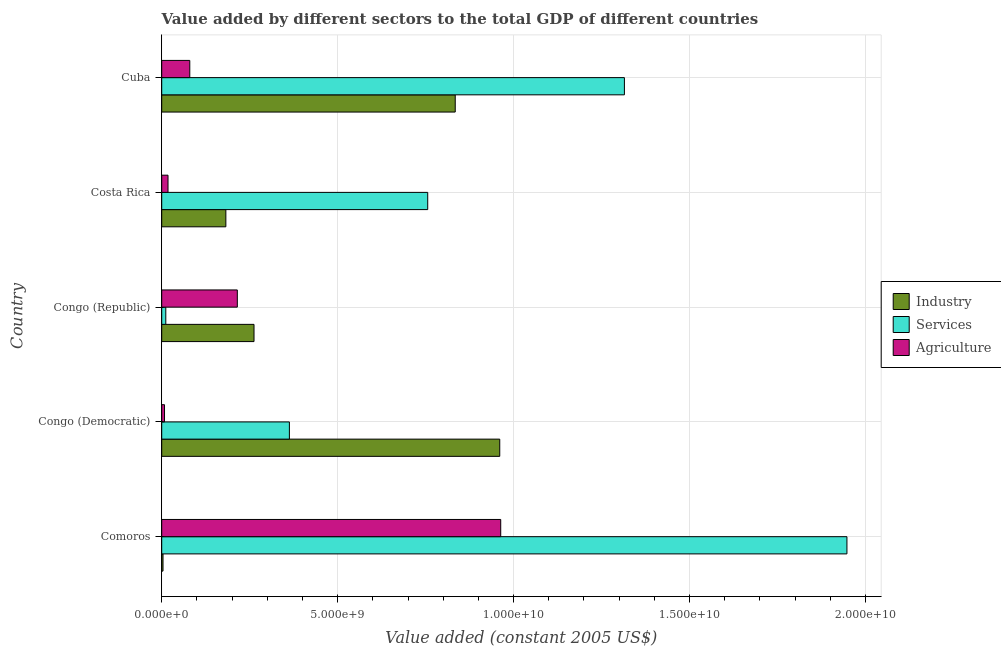How many different coloured bars are there?
Offer a terse response. 3. How many groups of bars are there?
Your answer should be very brief. 5. How many bars are there on the 5th tick from the bottom?
Provide a succinct answer. 3. What is the label of the 3rd group of bars from the top?
Ensure brevity in your answer.  Congo (Republic). In how many cases, is the number of bars for a given country not equal to the number of legend labels?
Offer a very short reply. 0. What is the value added by services in Cuba?
Offer a very short reply. 1.32e+1. Across all countries, what is the maximum value added by agricultural sector?
Provide a short and direct response. 9.64e+09. Across all countries, what is the minimum value added by industrial sector?
Offer a very short reply. 3.69e+07. In which country was the value added by services maximum?
Your response must be concise. Comoros. In which country was the value added by services minimum?
Your response must be concise. Congo (Republic). What is the total value added by agricultural sector in the graph?
Keep it short and to the point. 1.28e+1. What is the difference between the value added by industrial sector in Comoros and that in Costa Rica?
Ensure brevity in your answer.  -1.79e+09. What is the difference between the value added by agricultural sector in Congo (Democratic) and the value added by industrial sector in Comoros?
Keep it short and to the point. 4.30e+07. What is the average value added by agricultural sector per country?
Your answer should be compact. 2.57e+09. What is the difference between the value added by agricultural sector and value added by industrial sector in Costa Rica?
Ensure brevity in your answer.  -1.64e+09. What is the ratio of the value added by services in Costa Rica to that in Cuba?
Make the answer very short. 0.57. Is the value added by industrial sector in Congo (Republic) less than that in Costa Rica?
Your answer should be very brief. No. Is the difference between the value added by agricultural sector in Comoros and Costa Rica greater than the difference between the value added by industrial sector in Comoros and Costa Rica?
Provide a succinct answer. Yes. What is the difference between the highest and the second highest value added by services?
Make the answer very short. 6.32e+09. What is the difference between the highest and the lowest value added by services?
Make the answer very short. 1.94e+1. In how many countries, is the value added by industrial sector greater than the average value added by industrial sector taken over all countries?
Offer a very short reply. 2. Is the sum of the value added by industrial sector in Congo (Democratic) and Congo (Republic) greater than the maximum value added by services across all countries?
Give a very brief answer. No. What does the 2nd bar from the top in Congo (Democratic) represents?
Provide a succinct answer. Services. What does the 3rd bar from the bottom in Costa Rica represents?
Your response must be concise. Agriculture. Is it the case that in every country, the sum of the value added by industrial sector and value added by services is greater than the value added by agricultural sector?
Make the answer very short. Yes. Are all the bars in the graph horizontal?
Provide a succinct answer. Yes. How many countries are there in the graph?
Your answer should be compact. 5. What is the difference between two consecutive major ticks on the X-axis?
Your answer should be compact. 5.00e+09. Does the graph contain any zero values?
Provide a short and direct response. No. How many legend labels are there?
Provide a succinct answer. 3. How are the legend labels stacked?
Your answer should be compact. Vertical. What is the title of the graph?
Offer a terse response. Value added by different sectors to the total GDP of different countries. What is the label or title of the X-axis?
Keep it short and to the point. Value added (constant 2005 US$). What is the Value added (constant 2005 US$) in Industry in Comoros?
Ensure brevity in your answer.  3.69e+07. What is the Value added (constant 2005 US$) in Services in Comoros?
Ensure brevity in your answer.  1.95e+1. What is the Value added (constant 2005 US$) of Agriculture in Comoros?
Ensure brevity in your answer.  9.64e+09. What is the Value added (constant 2005 US$) in Industry in Congo (Democratic)?
Make the answer very short. 9.61e+09. What is the Value added (constant 2005 US$) of Services in Congo (Democratic)?
Give a very brief answer. 3.63e+09. What is the Value added (constant 2005 US$) of Agriculture in Congo (Democratic)?
Provide a succinct answer. 7.98e+07. What is the Value added (constant 2005 US$) of Industry in Congo (Republic)?
Your response must be concise. 2.62e+09. What is the Value added (constant 2005 US$) of Services in Congo (Republic)?
Your answer should be very brief. 1.16e+08. What is the Value added (constant 2005 US$) in Agriculture in Congo (Republic)?
Offer a terse response. 2.15e+09. What is the Value added (constant 2005 US$) of Industry in Costa Rica?
Your answer should be compact. 1.82e+09. What is the Value added (constant 2005 US$) in Services in Costa Rica?
Make the answer very short. 7.56e+09. What is the Value added (constant 2005 US$) in Agriculture in Costa Rica?
Your answer should be compact. 1.79e+08. What is the Value added (constant 2005 US$) in Industry in Cuba?
Ensure brevity in your answer.  8.34e+09. What is the Value added (constant 2005 US$) in Services in Cuba?
Give a very brief answer. 1.32e+1. What is the Value added (constant 2005 US$) of Agriculture in Cuba?
Your answer should be very brief. 7.98e+08. Across all countries, what is the maximum Value added (constant 2005 US$) in Industry?
Keep it short and to the point. 9.61e+09. Across all countries, what is the maximum Value added (constant 2005 US$) in Services?
Make the answer very short. 1.95e+1. Across all countries, what is the maximum Value added (constant 2005 US$) of Agriculture?
Your answer should be very brief. 9.64e+09. Across all countries, what is the minimum Value added (constant 2005 US$) in Industry?
Keep it short and to the point. 3.69e+07. Across all countries, what is the minimum Value added (constant 2005 US$) in Services?
Your answer should be compact. 1.16e+08. Across all countries, what is the minimum Value added (constant 2005 US$) of Agriculture?
Keep it short and to the point. 7.98e+07. What is the total Value added (constant 2005 US$) of Industry in the graph?
Your response must be concise. 2.24e+1. What is the total Value added (constant 2005 US$) of Services in the graph?
Offer a very short reply. 4.39e+1. What is the total Value added (constant 2005 US$) of Agriculture in the graph?
Your response must be concise. 1.28e+1. What is the difference between the Value added (constant 2005 US$) in Industry in Comoros and that in Congo (Democratic)?
Your answer should be very brief. -9.57e+09. What is the difference between the Value added (constant 2005 US$) of Services in Comoros and that in Congo (Democratic)?
Provide a short and direct response. 1.58e+1. What is the difference between the Value added (constant 2005 US$) in Agriculture in Comoros and that in Congo (Democratic)?
Offer a terse response. 9.56e+09. What is the difference between the Value added (constant 2005 US$) of Industry in Comoros and that in Congo (Republic)?
Your answer should be compact. -2.59e+09. What is the difference between the Value added (constant 2005 US$) in Services in Comoros and that in Congo (Republic)?
Offer a terse response. 1.94e+1. What is the difference between the Value added (constant 2005 US$) of Agriculture in Comoros and that in Congo (Republic)?
Make the answer very short. 7.49e+09. What is the difference between the Value added (constant 2005 US$) of Industry in Comoros and that in Costa Rica?
Offer a terse response. -1.79e+09. What is the difference between the Value added (constant 2005 US$) of Services in Comoros and that in Costa Rica?
Offer a terse response. 1.19e+1. What is the difference between the Value added (constant 2005 US$) of Agriculture in Comoros and that in Costa Rica?
Your answer should be very brief. 9.46e+09. What is the difference between the Value added (constant 2005 US$) in Industry in Comoros and that in Cuba?
Your answer should be compact. -8.31e+09. What is the difference between the Value added (constant 2005 US$) of Services in Comoros and that in Cuba?
Your answer should be compact. 6.32e+09. What is the difference between the Value added (constant 2005 US$) of Agriculture in Comoros and that in Cuba?
Make the answer very short. 8.84e+09. What is the difference between the Value added (constant 2005 US$) in Industry in Congo (Democratic) and that in Congo (Republic)?
Give a very brief answer. 6.98e+09. What is the difference between the Value added (constant 2005 US$) of Services in Congo (Democratic) and that in Congo (Republic)?
Ensure brevity in your answer.  3.51e+09. What is the difference between the Value added (constant 2005 US$) in Agriculture in Congo (Democratic) and that in Congo (Republic)?
Provide a succinct answer. -2.07e+09. What is the difference between the Value added (constant 2005 US$) in Industry in Congo (Democratic) and that in Costa Rica?
Your answer should be very brief. 7.78e+09. What is the difference between the Value added (constant 2005 US$) of Services in Congo (Democratic) and that in Costa Rica?
Offer a very short reply. -3.93e+09. What is the difference between the Value added (constant 2005 US$) of Agriculture in Congo (Democratic) and that in Costa Rica?
Offer a terse response. -9.93e+07. What is the difference between the Value added (constant 2005 US$) of Industry in Congo (Democratic) and that in Cuba?
Make the answer very short. 1.27e+09. What is the difference between the Value added (constant 2005 US$) of Services in Congo (Democratic) and that in Cuba?
Provide a succinct answer. -9.52e+09. What is the difference between the Value added (constant 2005 US$) in Agriculture in Congo (Democratic) and that in Cuba?
Keep it short and to the point. -7.18e+08. What is the difference between the Value added (constant 2005 US$) in Industry in Congo (Republic) and that in Costa Rica?
Provide a succinct answer. 8.00e+08. What is the difference between the Value added (constant 2005 US$) in Services in Congo (Republic) and that in Costa Rica?
Ensure brevity in your answer.  -7.44e+09. What is the difference between the Value added (constant 2005 US$) in Agriculture in Congo (Republic) and that in Costa Rica?
Ensure brevity in your answer.  1.97e+09. What is the difference between the Value added (constant 2005 US$) of Industry in Congo (Republic) and that in Cuba?
Your answer should be compact. -5.72e+09. What is the difference between the Value added (constant 2005 US$) of Services in Congo (Republic) and that in Cuba?
Provide a short and direct response. -1.30e+1. What is the difference between the Value added (constant 2005 US$) of Agriculture in Congo (Republic) and that in Cuba?
Give a very brief answer. 1.35e+09. What is the difference between the Value added (constant 2005 US$) in Industry in Costa Rica and that in Cuba?
Keep it short and to the point. -6.52e+09. What is the difference between the Value added (constant 2005 US$) in Services in Costa Rica and that in Cuba?
Ensure brevity in your answer.  -5.59e+09. What is the difference between the Value added (constant 2005 US$) in Agriculture in Costa Rica and that in Cuba?
Provide a succinct answer. -6.19e+08. What is the difference between the Value added (constant 2005 US$) in Industry in Comoros and the Value added (constant 2005 US$) in Services in Congo (Democratic)?
Ensure brevity in your answer.  -3.59e+09. What is the difference between the Value added (constant 2005 US$) in Industry in Comoros and the Value added (constant 2005 US$) in Agriculture in Congo (Democratic)?
Offer a very short reply. -4.30e+07. What is the difference between the Value added (constant 2005 US$) of Services in Comoros and the Value added (constant 2005 US$) of Agriculture in Congo (Democratic)?
Provide a short and direct response. 1.94e+1. What is the difference between the Value added (constant 2005 US$) in Industry in Comoros and the Value added (constant 2005 US$) in Services in Congo (Republic)?
Offer a very short reply. -7.93e+07. What is the difference between the Value added (constant 2005 US$) of Industry in Comoros and the Value added (constant 2005 US$) of Agriculture in Congo (Republic)?
Provide a succinct answer. -2.11e+09. What is the difference between the Value added (constant 2005 US$) of Services in Comoros and the Value added (constant 2005 US$) of Agriculture in Congo (Republic)?
Provide a short and direct response. 1.73e+1. What is the difference between the Value added (constant 2005 US$) in Industry in Comoros and the Value added (constant 2005 US$) in Services in Costa Rica?
Offer a very short reply. -7.52e+09. What is the difference between the Value added (constant 2005 US$) of Industry in Comoros and the Value added (constant 2005 US$) of Agriculture in Costa Rica?
Provide a succinct answer. -1.42e+08. What is the difference between the Value added (constant 2005 US$) of Services in Comoros and the Value added (constant 2005 US$) of Agriculture in Costa Rica?
Offer a terse response. 1.93e+1. What is the difference between the Value added (constant 2005 US$) in Industry in Comoros and the Value added (constant 2005 US$) in Services in Cuba?
Provide a short and direct response. -1.31e+1. What is the difference between the Value added (constant 2005 US$) of Industry in Comoros and the Value added (constant 2005 US$) of Agriculture in Cuba?
Give a very brief answer. -7.61e+08. What is the difference between the Value added (constant 2005 US$) in Services in Comoros and the Value added (constant 2005 US$) in Agriculture in Cuba?
Keep it short and to the point. 1.87e+1. What is the difference between the Value added (constant 2005 US$) of Industry in Congo (Democratic) and the Value added (constant 2005 US$) of Services in Congo (Republic)?
Keep it short and to the point. 9.49e+09. What is the difference between the Value added (constant 2005 US$) of Industry in Congo (Democratic) and the Value added (constant 2005 US$) of Agriculture in Congo (Republic)?
Your answer should be compact. 7.46e+09. What is the difference between the Value added (constant 2005 US$) of Services in Congo (Democratic) and the Value added (constant 2005 US$) of Agriculture in Congo (Republic)?
Your answer should be very brief. 1.48e+09. What is the difference between the Value added (constant 2005 US$) in Industry in Congo (Democratic) and the Value added (constant 2005 US$) in Services in Costa Rica?
Offer a very short reply. 2.05e+09. What is the difference between the Value added (constant 2005 US$) of Industry in Congo (Democratic) and the Value added (constant 2005 US$) of Agriculture in Costa Rica?
Give a very brief answer. 9.43e+09. What is the difference between the Value added (constant 2005 US$) in Services in Congo (Democratic) and the Value added (constant 2005 US$) in Agriculture in Costa Rica?
Offer a very short reply. 3.45e+09. What is the difference between the Value added (constant 2005 US$) in Industry in Congo (Democratic) and the Value added (constant 2005 US$) in Services in Cuba?
Offer a very short reply. -3.54e+09. What is the difference between the Value added (constant 2005 US$) in Industry in Congo (Democratic) and the Value added (constant 2005 US$) in Agriculture in Cuba?
Keep it short and to the point. 8.81e+09. What is the difference between the Value added (constant 2005 US$) in Services in Congo (Democratic) and the Value added (constant 2005 US$) in Agriculture in Cuba?
Offer a very short reply. 2.83e+09. What is the difference between the Value added (constant 2005 US$) of Industry in Congo (Republic) and the Value added (constant 2005 US$) of Services in Costa Rica?
Ensure brevity in your answer.  -4.94e+09. What is the difference between the Value added (constant 2005 US$) of Industry in Congo (Republic) and the Value added (constant 2005 US$) of Agriculture in Costa Rica?
Keep it short and to the point. 2.44e+09. What is the difference between the Value added (constant 2005 US$) in Services in Congo (Republic) and the Value added (constant 2005 US$) in Agriculture in Costa Rica?
Your response must be concise. -6.30e+07. What is the difference between the Value added (constant 2005 US$) of Industry in Congo (Republic) and the Value added (constant 2005 US$) of Services in Cuba?
Offer a very short reply. -1.05e+1. What is the difference between the Value added (constant 2005 US$) of Industry in Congo (Republic) and the Value added (constant 2005 US$) of Agriculture in Cuba?
Offer a terse response. 1.83e+09. What is the difference between the Value added (constant 2005 US$) of Services in Congo (Republic) and the Value added (constant 2005 US$) of Agriculture in Cuba?
Your answer should be very brief. -6.82e+08. What is the difference between the Value added (constant 2005 US$) of Industry in Costa Rica and the Value added (constant 2005 US$) of Services in Cuba?
Give a very brief answer. -1.13e+1. What is the difference between the Value added (constant 2005 US$) of Industry in Costa Rica and the Value added (constant 2005 US$) of Agriculture in Cuba?
Give a very brief answer. 1.03e+09. What is the difference between the Value added (constant 2005 US$) in Services in Costa Rica and the Value added (constant 2005 US$) in Agriculture in Cuba?
Offer a very short reply. 6.76e+09. What is the average Value added (constant 2005 US$) in Industry per country?
Provide a short and direct response. 4.49e+09. What is the average Value added (constant 2005 US$) of Services per country?
Make the answer very short. 8.79e+09. What is the average Value added (constant 2005 US$) in Agriculture per country?
Ensure brevity in your answer.  2.57e+09. What is the difference between the Value added (constant 2005 US$) of Industry and Value added (constant 2005 US$) of Services in Comoros?
Keep it short and to the point. -1.94e+1. What is the difference between the Value added (constant 2005 US$) in Industry and Value added (constant 2005 US$) in Agriculture in Comoros?
Give a very brief answer. -9.60e+09. What is the difference between the Value added (constant 2005 US$) in Services and Value added (constant 2005 US$) in Agriculture in Comoros?
Make the answer very short. 9.84e+09. What is the difference between the Value added (constant 2005 US$) in Industry and Value added (constant 2005 US$) in Services in Congo (Democratic)?
Give a very brief answer. 5.98e+09. What is the difference between the Value added (constant 2005 US$) of Industry and Value added (constant 2005 US$) of Agriculture in Congo (Democratic)?
Your answer should be very brief. 9.53e+09. What is the difference between the Value added (constant 2005 US$) in Services and Value added (constant 2005 US$) in Agriculture in Congo (Democratic)?
Keep it short and to the point. 3.55e+09. What is the difference between the Value added (constant 2005 US$) in Industry and Value added (constant 2005 US$) in Services in Congo (Republic)?
Keep it short and to the point. 2.51e+09. What is the difference between the Value added (constant 2005 US$) of Industry and Value added (constant 2005 US$) of Agriculture in Congo (Republic)?
Your answer should be very brief. 4.74e+08. What is the difference between the Value added (constant 2005 US$) in Services and Value added (constant 2005 US$) in Agriculture in Congo (Republic)?
Provide a short and direct response. -2.03e+09. What is the difference between the Value added (constant 2005 US$) of Industry and Value added (constant 2005 US$) of Services in Costa Rica?
Offer a very short reply. -5.74e+09. What is the difference between the Value added (constant 2005 US$) of Industry and Value added (constant 2005 US$) of Agriculture in Costa Rica?
Your response must be concise. 1.64e+09. What is the difference between the Value added (constant 2005 US$) in Services and Value added (constant 2005 US$) in Agriculture in Costa Rica?
Provide a succinct answer. 7.38e+09. What is the difference between the Value added (constant 2005 US$) in Industry and Value added (constant 2005 US$) in Services in Cuba?
Provide a succinct answer. -4.81e+09. What is the difference between the Value added (constant 2005 US$) in Industry and Value added (constant 2005 US$) in Agriculture in Cuba?
Provide a succinct answer. 7.54e+09. What is the difference between the Value added (constant 2005 US$) of Services and Value added (constant 2005 US$) of Agriculture in Cuba?
Offer a very short reply. 1.24e+1. What is the ratio of the Value added (constant 2005 US$) in Industry in Comoros to that in Congo (Democratic)?
Offer a terse response. 0. What is the ratio of the Value added (constant 2005 US$) of Services in Comoros to that in Congo (Democratic)?
Your answer should be compact. 5.37. What is the ratio of the Value added (constant 2005 US$) of Agriculture in Comoros to that in Congo (Democratic)?
Offer a very short reply. 120.68. What is the ratio of the Value added (constant 2005 US$) in Industry in Comoros to that in Congo (Republic)?
Offer a terse response. 0.01. What is the ratio of the Value added (constant 2005 US$) of Services in Comoros to that in Congo (Republic)?
Keep it short and to the point. 167.65. What is the ratio of the Value added (constant 2005 US$) in Agriculture in Comoros to that in Congo (Republic)?
Give a very brief answer. 4.48. What is the ratio of the Value added (constant 2005 US$) in Industry in Comoros to that in Costa Rica?
Your answer should be very brief. 0.02. What is the ratio of the Value added (constant 2005 US$) in Services in Comoros to that in Costa Rica?
Provide a short and direct response. 2.58. What is the ratio of the Value added (constant 2005 US$) in Agriculture in Comoros to that in Costa Rica?
Provide a succinct answer. 53.79. What is the ratio of the Value added (constant 2005 US$) of Industry in Comoros to that in Cuba?
Your response must be concise. 0. What is the ratio of the Value added (constant 2005 US$) of Services in Comoros to that in Cuba?
Give a very brief answer. 1.48. What is the ratio of the Value added (constant 2005 US$) in Agriculture in Comoros to that in Cuba?
Your answer should be very brief. 12.08. What is the ratio of the Value added (constant 2005 US$) in Industry in Congo (Democratic) to that in Congo (Republic)?
Give a very brief answer. 3.66. What is the ratio of the Value added (constant 2005 US$) of Services in Congo (Democratic) to that in Congo (Republic)?
Provide a short and direct response. 31.24. What is the ratio of the Value added (constant 2005 US$) in Agriculture in Congo (Democratic) to that in Congo (Republic)?
Your response must be concise. 0.04. What is the ratio of the Value added (constant 2005 US$) in Industry in Congo (Democratic) to that in Costa Rica?
Your answer should be very brief. 5.27. What is the ratio of the Value added (constant 2005 US$) in Services in Congo (Democratic) to that in Costa Rica?
Offer a terse response. 0.48. What is the ratio of the Value added (constant 2005 US$) in Agriculture in Congo (Democratic) to that in Costa Rica?
Offer a terse response. 0.45. What is the ratio of the Value added (constant 2005 US$) in Industry in Congo (Democratic) to that in Cuba?
Your answer should be compact. 1.15. What is the ratio of the Value added (constant 2005 US$) in Services in Congo (Democratic) to that in Cuba?
Offer a very short reply. 0.28. What is the ratio of the Value added (constant 2005 US$) in Agriculture in Congo (Democratic) to that in Cuba?
Provide a succinct answer. 0.1. What is the ratio of the Value added (constant 2005 US$) of Industry in Congo (Republic) to that in Costa Rica?
Make the answer very short. 1.44. What is the ratio of the Value added (constant 2005 US$) of Services in Congo (Republic) to that in Costa Rica?
Provide a succinct answer. 0.02. What is the ratio of the Value added (constant 2005 US$) in Agriculture in Congo (Republic) to that in Costa Rica?
Your answer should be very brief. 12. What is the ratio of the Value added (constant 2005 US$) of Industry in Congo (Republic) to that in Cuba?
Offer a terse response. 0.31. What is the ratio of the Value added (constant 2005 US$) of Services in Congo (Republic) to that in Cuba?
Your answer should be very brief. 0.01. What is the ratio of the Value added (constant 2005 US$) of Agriculture in Congo (Republic) to that in Cuba?
Ensure brevity in your answer.  2.69. What is the ratio of the Value added (constant 2005 US$) of Industry in Costa Rica to that in Cuba?
Your response must be concise. 0.22. What is the ratio of the Value added (constant 2005 US$) in Services in Costa Rica to that in Cuba?
Your answer should be very brief. 0.57. What is the ratio of the Value added (constant 2005 US$) in Agriculture in Costa Rica to that in Cuba?
Make the answer very short. 0.22. What is the difference between the highest and the second highest Value added (constant 2005 US$) of Industry?
Provide a short and direct response. 1.27e+09. What is the difference between the highest and the second highest Value added (constant 2005 US$) in Services?
Keep it short and to the point. 6.32e+09. What is the difference between the highest and the second highest Value added (constant 2005 US$) of Agriculture?
Offer a terse response. 7.49e+09. What is the difference between the highest and the lowest Value added (constant 2005 US$) of Industry?
Provide a short and direct response. 9.57e+09. What is the difference between the highest and the lowest Value added (constant 2005 US$) in Services?
Offer a very short reply. 1.94e+1. What is the difference between the highest and the lowest Value added (constant 2005 US$) of Agriculture?
Make the answer very short. 9.56e+09. 